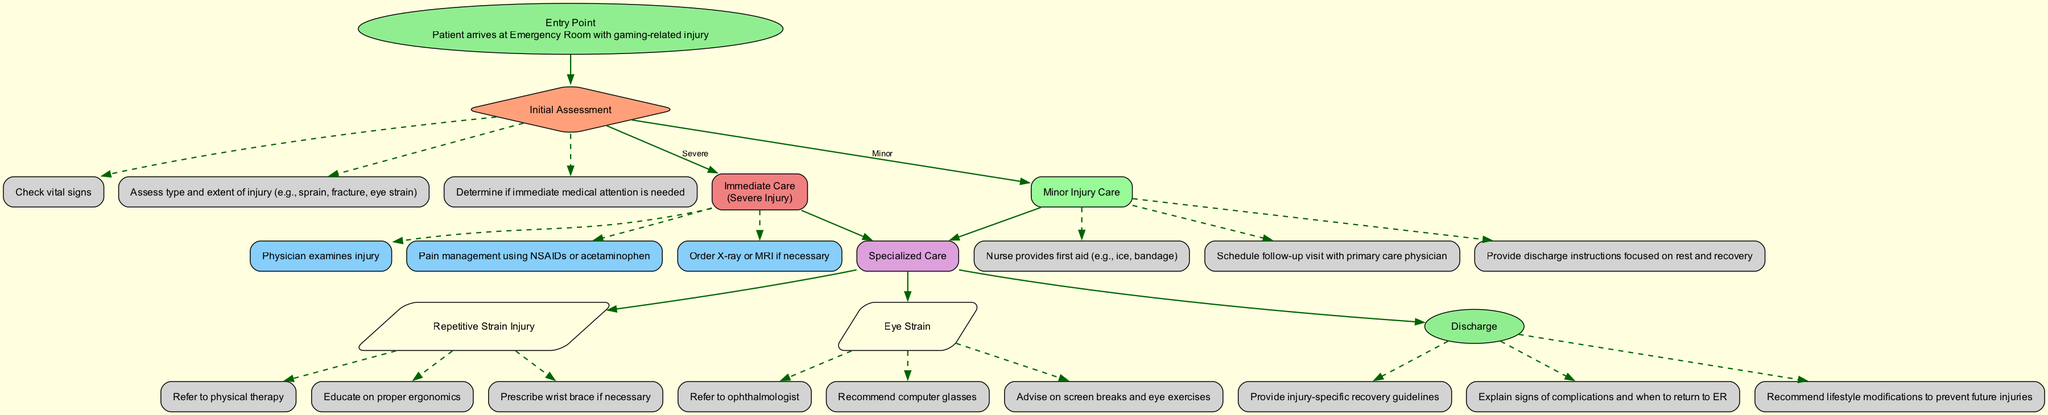What is the entry point of the clinical pathway? The entry point is where the patient arrives at the Emergency Room with a gaming-related injury. This is the first node in the diagram that initiates the clinical pathway.
Answer: Patient arrives at Emergency Room with gaming-related injury How many immediate care actions are there? In the Immediate Care section, there are three actions listed: physician examines injury, pain management, and order X-ray or MRI if necessary. This involves counting the actions connected to the Immediate Care node.
Answer: 3 What must the triage nurse assess initially? The initial assessment includes checking vital signs, assessing the type and extent of injury, and determining if immediate medical attention is needed. These are the three specific components detailed in the diagram under the Initial Assessment.
Answer: Vital signs, injury assessment, medical attention need What happens if a patient has a minor injury? If the injury is minor, the nurse provides first aid, schedules a follow-up visit, and provides discharge instructions. This flow is derived from the Minor Injury Care section, which describes the actions taken for minor injuries.
Answer: Nurse provides first aid, schedule follow-up, discharge instructions What type of specialized care is recommended for eye strain? For eye strain, the recommended specialized care actions include referring to an ophthalmologist, recommending computer glasses, and advising on screen breaks and eye exercises. This information is found within the Eye Strain scenario under the Specialized Care section.
Answer: Refer to ophthalmologist, recommend computer glasses, advise on screen breaks How does a severe injury lead to specialized care? In the pathway, if a severe injury is present and after immediate care actions are taken, there's a direct edge connecting to the Specialized Care node, indicating that further specialized treatments may be needed based on the specific injury type.
Answer: Immediate care leads to specialized care What guidelines are included in the discharge? The discharge components include injury-specific recovery guidelines, signs of potential complications, and lifestyle modifications to prevent future injuries. This is summarized from the Discharge section that details what patients receive before leaving the ER.
Answer: Recovery guidelines, signs of complications, lifestyle modifications 